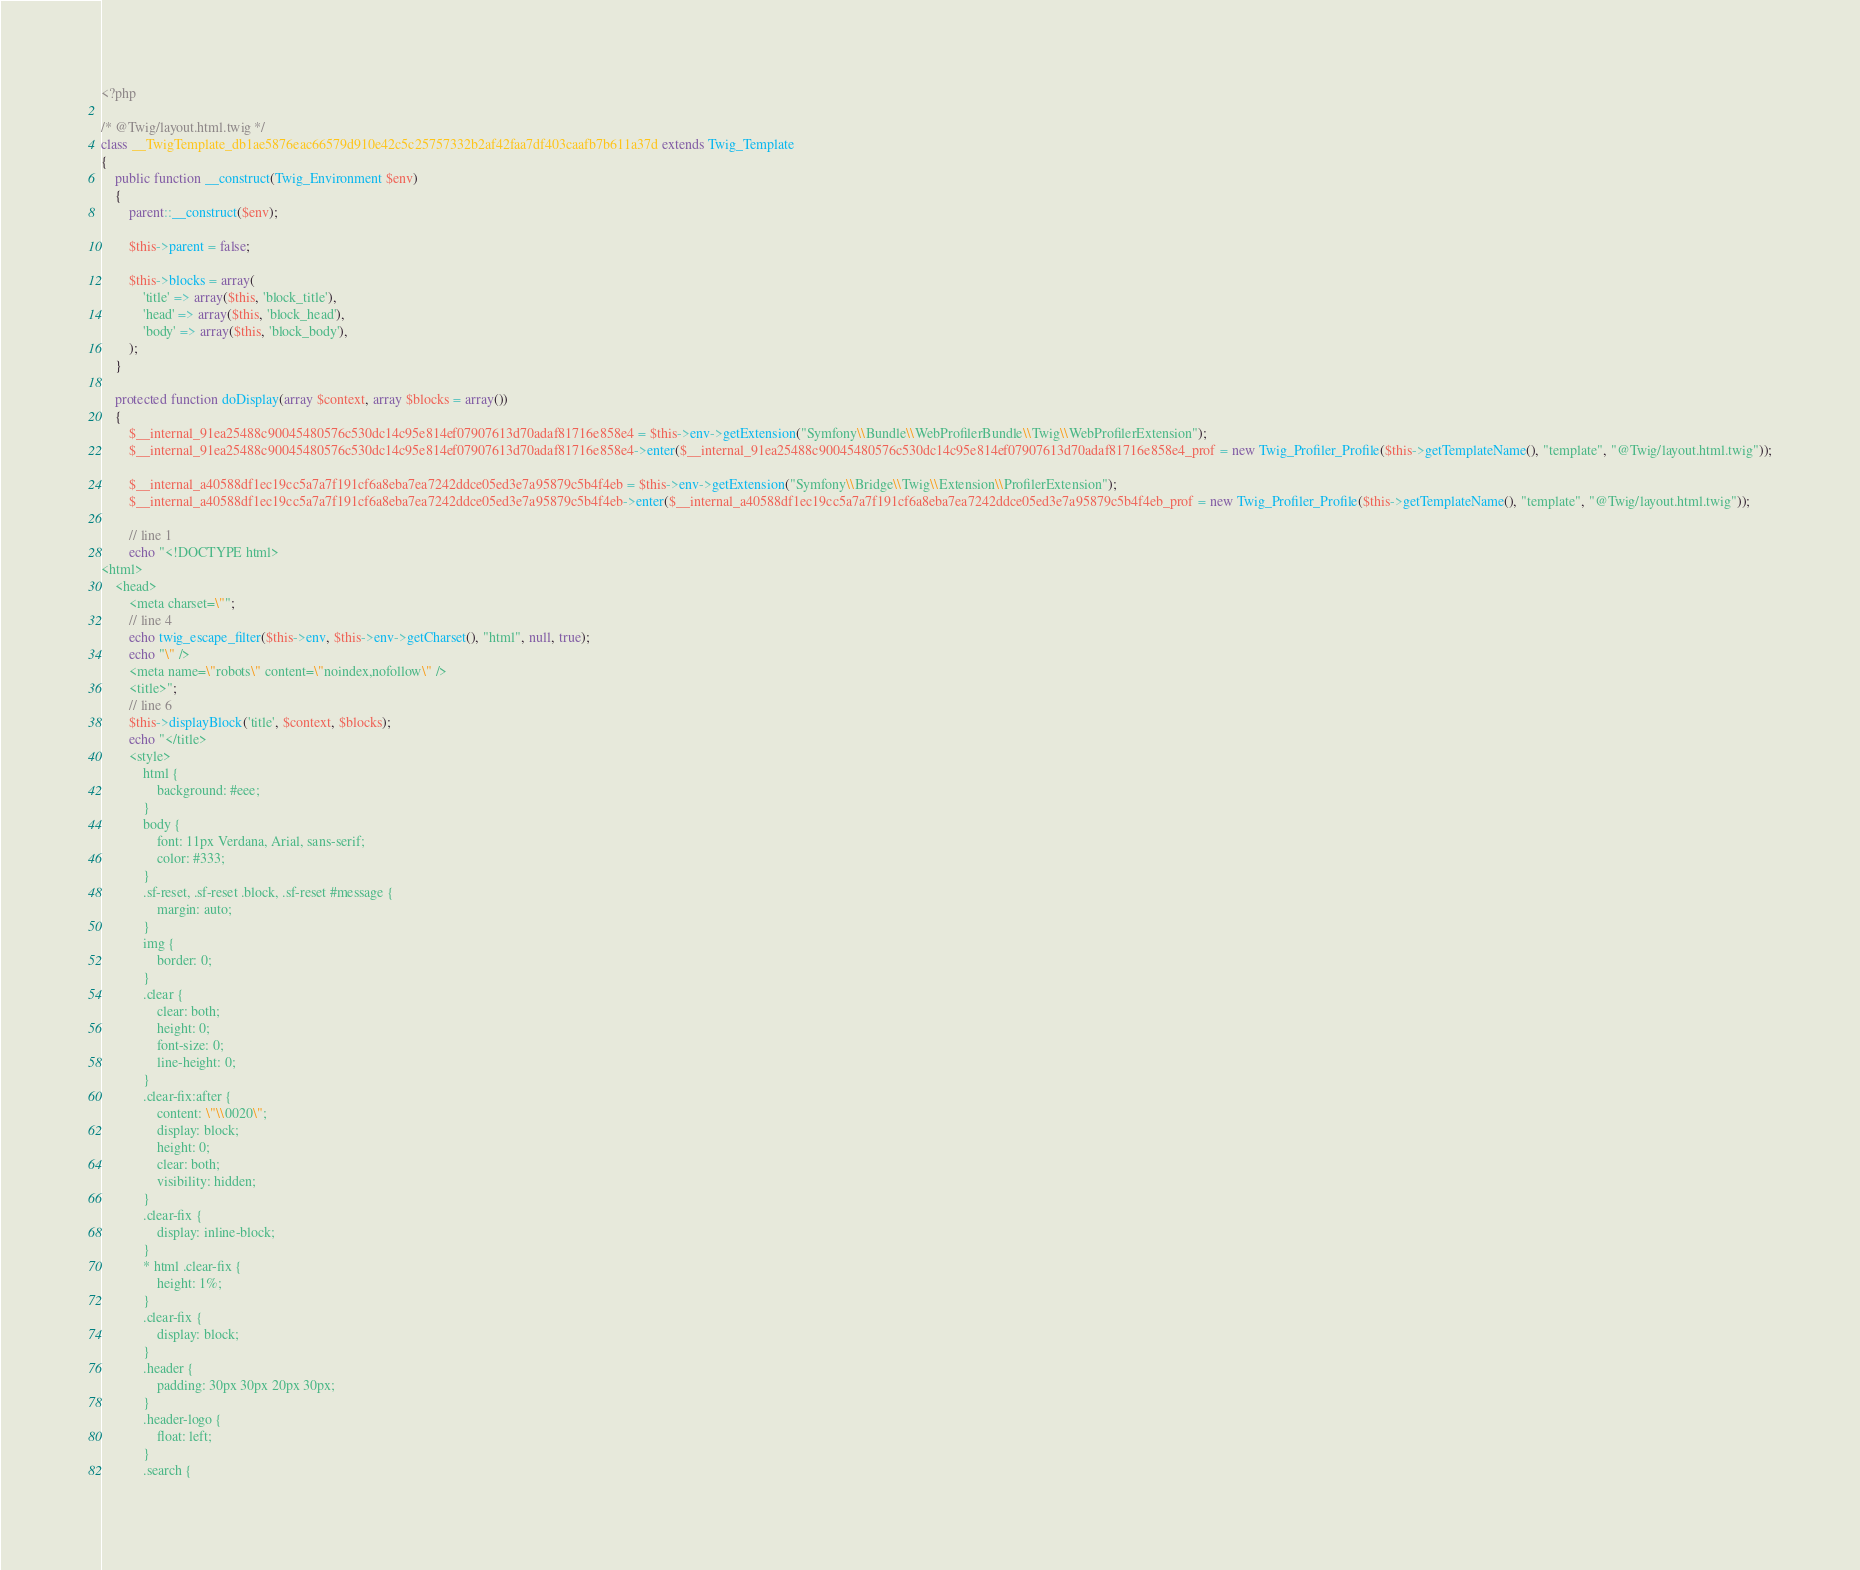<code> <loc_0><loc_0><loc_500><loc_500><_PHP_><?php

/* @Twig/layout.html.twig */
class __TwigTemplate_db1ae5876eac66579d910e42c5c25757332b2af42faa7df403caafb7b611a37d extends Twig_Template
{
    public function __construct(Twig_Environment $env)
    {
        parent::__construct($env);

        $this->parent = false;

        $this->blocks = array(
            'title' => array($this, 'block_title'),
            'head' => array($this, 'block_head'),
            'body' => array($this, 'block_body'),
        );
    }

    protected function doDisplay(array $context, array $blocks = array())
    {
        $__internal_91ea25488c90045480576c530dc14c95e814ef07907613d70adaf81716e858e4 = $this->env->getExtension("Symfony\\Bundle\\WebProfilerBundle\\Twig\\WebProfilerExtension");
        $__internal_91ea25488c90045480576c530dc14c95e814ef07907613d70adaf81716e858e4->enter($__internal_91ea25488c90045480576c530dc14c95e814ef07907613d70adaf81716e858e4_prof = new Twig_Profiler_Profile($this->getTemplateName(), "template", "@Twig/layout.html.twig"));

        $__internal_a40588df1ec19cc5a7a7f191cf6a8eba7ea7242ddce05ed3e7a95879c5b4f4eb = $this->env->getExtension("Symfony\\Bridge\\Twig\\Extension\\ProfilerExtension");
        $__internal_a40588df1ec19cc5a7a7f191cf6a8eba7ea7242ddce05ed3e7a95879c5b4f4eb->enter($__internal_a40588df1ec19cc5a7a7f191cf6a8eba7ea7242ddce05ed3e7a95879c5b4f4eb_prof = new Twig_Profiler_Profile($this->getTemplateName(), "template", "@Twig/layout.html.twig"));

        // line 1
        echo "<!DOCTYPE html>
<html>
    <head>
        <meta charset=\"";
        // line 4
        echo twig_escape_filter($this->env, $this->env->getCharset(), "html", null, true);
        echo "\" />
        <meta name=\"robots\" content=\"noindex,nofollow\" />
        <title>";
        // line 6
        $this->displayBlock('title', $context, $blocks);
        echo "</title>
        <style>
            html {
                background: #eee;
            }
            body {
                font: 11px Verdana, Arial, sans-serif;
                color: #333;
            }
            .sf-reset, .sf-reset .block, .sf-reset #message {
                margin: auto;
            }
            img {
                border: 0;
            }
            .clear {
                clear: both;
                height: 0;
                font-size: 0;
                line-height: 0;
            }
            .clear-fix:after {
                content: \"\\0020\";
                display: block;
                height: 0;
                clear: both;
                visibility: hidden;
            }
            .clear-fix {
                display: inline-block;
            }
            * html .clear-fix {
                height: 1%;
            }
            .clear-fix {
                display: block;
            }
            .header {
                padding: 30px 30px 20px 30px;
            }
            .header-logo {
                float: left;
            }
            .search {</code> 